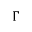Convert formula to latex. <formula><loc_0><loc_0><loc_500><loc_500>\Gamma</formula> 